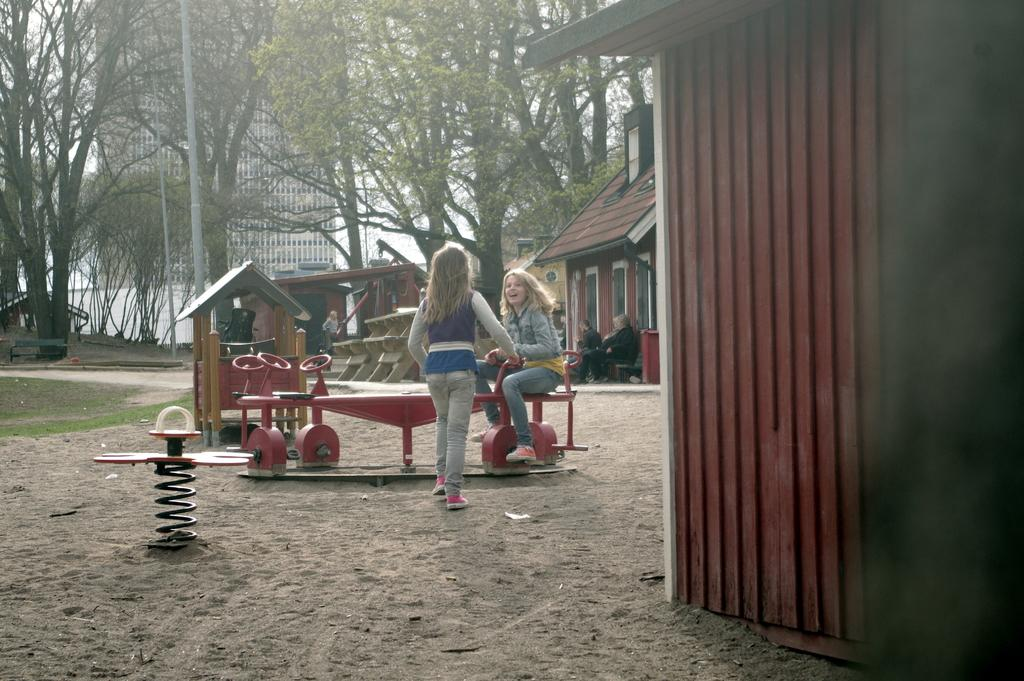How many people can be seen in the image? There are people in the image, but the exact number is not specified. What type of equipment is present in the image? Playground equipment is present in the image. What type of ground surface is visible in the image? Grass is visible in the image. What type of seating is available in the image? There is a bench in the image. What type of vegetation is present in the image? Trees are present in the image. What type of vertical structures are visible in the image? Poles are visible in the image. What type of storage structures are present in the image? There are sheds in the image. What type of structure is visible in the background of the image? There is a building in the background of the image. What part of the natural environment is visible in the background of the image? The sky is visible in the background of the image. What type of iron is being used to scare away birds in the image? There is no iron or scarecrow present in the image. What emotion can be seen on the people's faces in the image? The image does not provide enough detail to determine the emotions of the people in the image. 